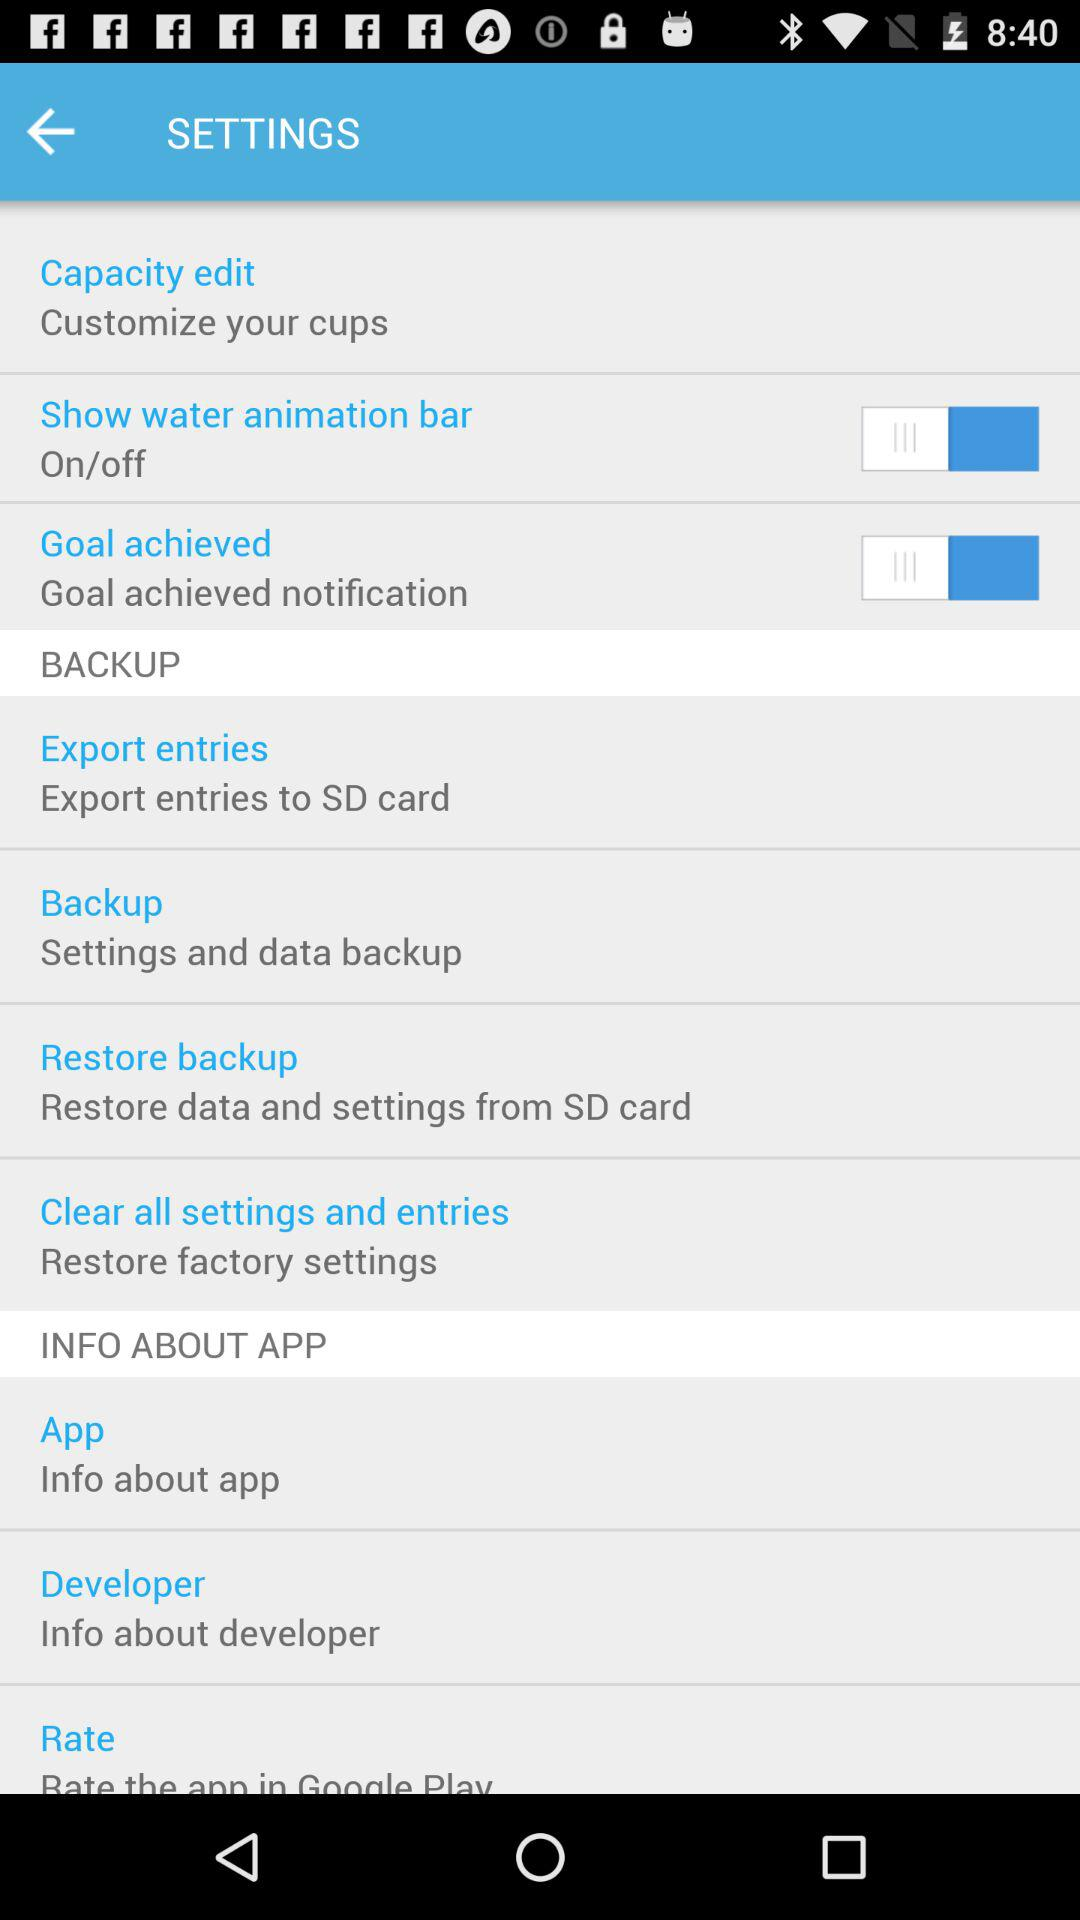What's the status of the "Show water animation bar"? The status is "off". 